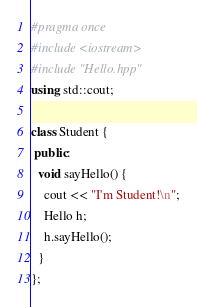<code> <loc_0><loc_0><loc_500><loc_500><_C++_>#pragma once
#include <iostream>
#include "Hello.hpp"
using std::cout;

class Student {
 public:
  void sayHello() {
    cout << "I'm Student!\n";
    Hello h;
    h.sayHello();
  }
};</code> 